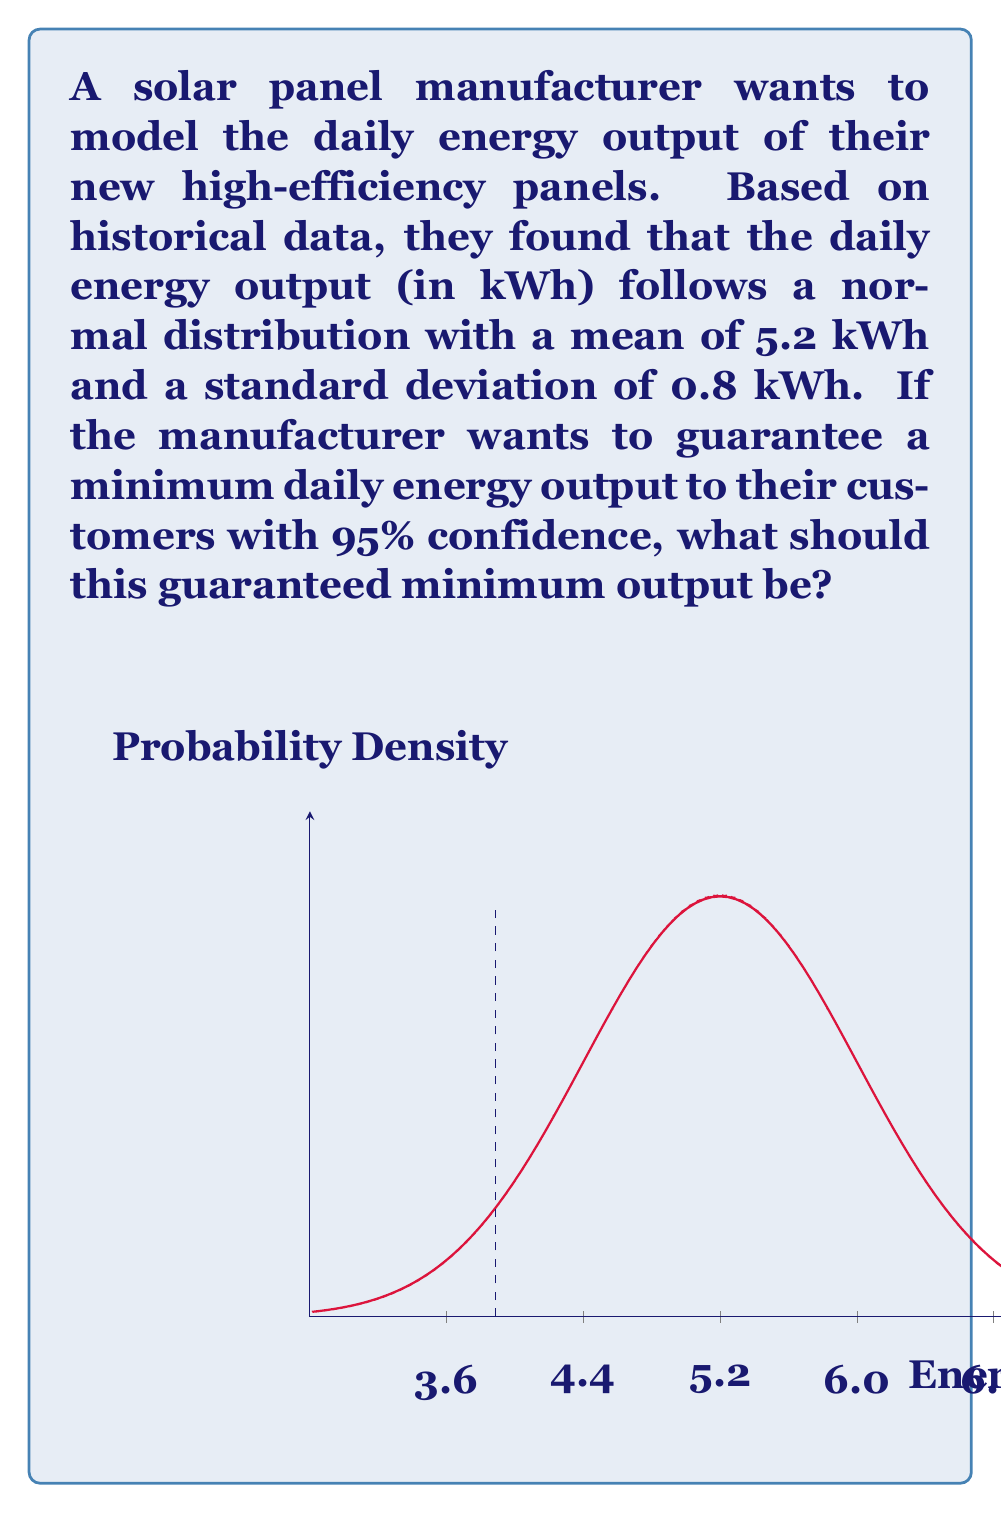Give your solution to this math problem. To solve this problem, we'll use the properties of the normal distribution and the concept of z-scores.

1) We're given:
   - Mean (μ) = 5.2 kWh
   - Standard deviation (σ) = 0.8 kWh
   - Confidence level = 95%

2) For a 95% confidence level, we need to find the z-score that leaves 5% in the lower tail of the distribution. This z-score is -1.645 (from standard normal distribution tables or calculators).

3) The formula to convert from z-score to x-value is:
   $$ x = μ + (z * σ) $$

4) Plugging in our values:
   $$ x = 5.2 + (-1.645 * 0.8) $$

5) Calculating:
   $$ x = 5.2 - 1.316 = 3.884 $$

6) Rounding to a reasonable precision for energy output:
   $$ x ≈ 3.88 \text{ kWh} $$

This means that 95% of the time, the daily energy output will be above 3.88 kWh.
Answer: 3.88 kWh 